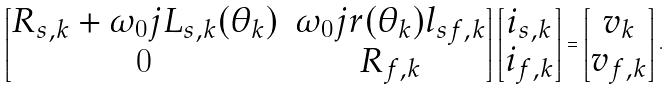Convert formula to latex. <formula><loc_0><loc_0><loc_500><loc_500>\begin{bmatrix} R _ { s , k } + \omega _ { 0 } j L _ { s , k } ( \theta _ { k } ) & \omega _ { 0 } j r ( \theta _ { k } ) l _ { s f , k } \\ 0 & R _ { f , k } \end{bmatrix} \begin{bmatrix} i _ { s , k } \\ i _ { f , k } \end{bmatrix} = \begin{bmatrix} v _ { k } \\ v _ { f , k } \end{bmatrix} .</formula> 